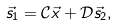<formula> <loc_0><loc_0><loc_500><loc_500>\vec { s } _ { 1 } = \mathcal { C } \vec { x } + \mathcal { D } \vec { s } _ { 2 } ,</formula> 